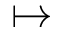<formula> <loc_0><loc_0><loc_500><loc_500>\mapsto</formula> 